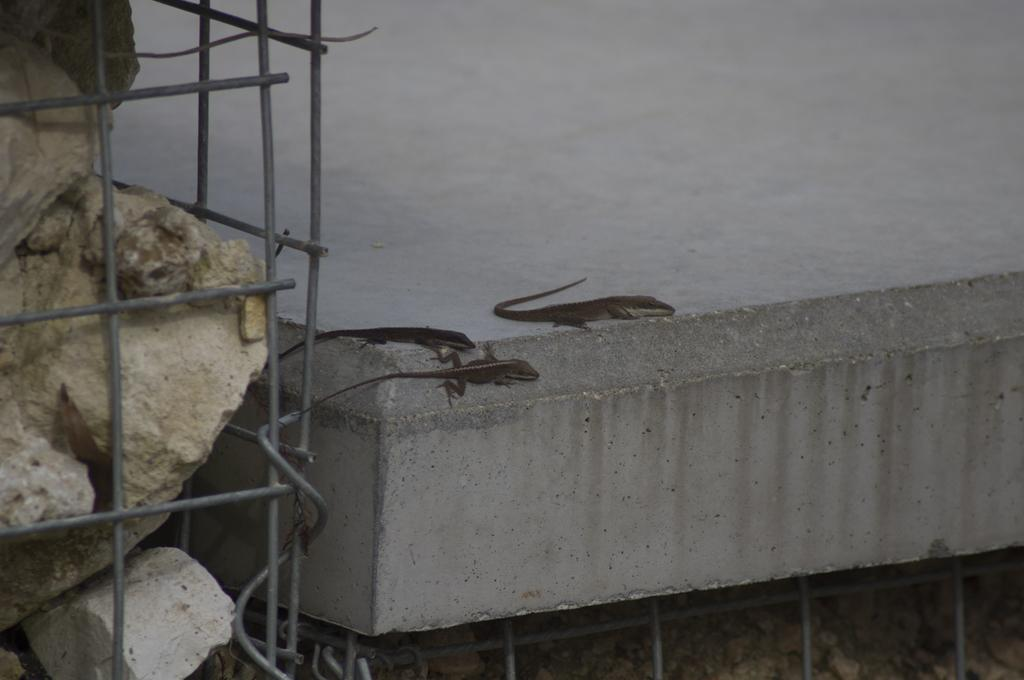How many lizards are present in the image? There are three lizards in the image. Where are the lizards located? The lizards are on a platform in the image. What other objects can be seen in the image? There are stones and rods in the image. What type of hat is the mother wearing in the image? There is no mother or hat present in the image; it features three lizards on a platform with stones and rods. 